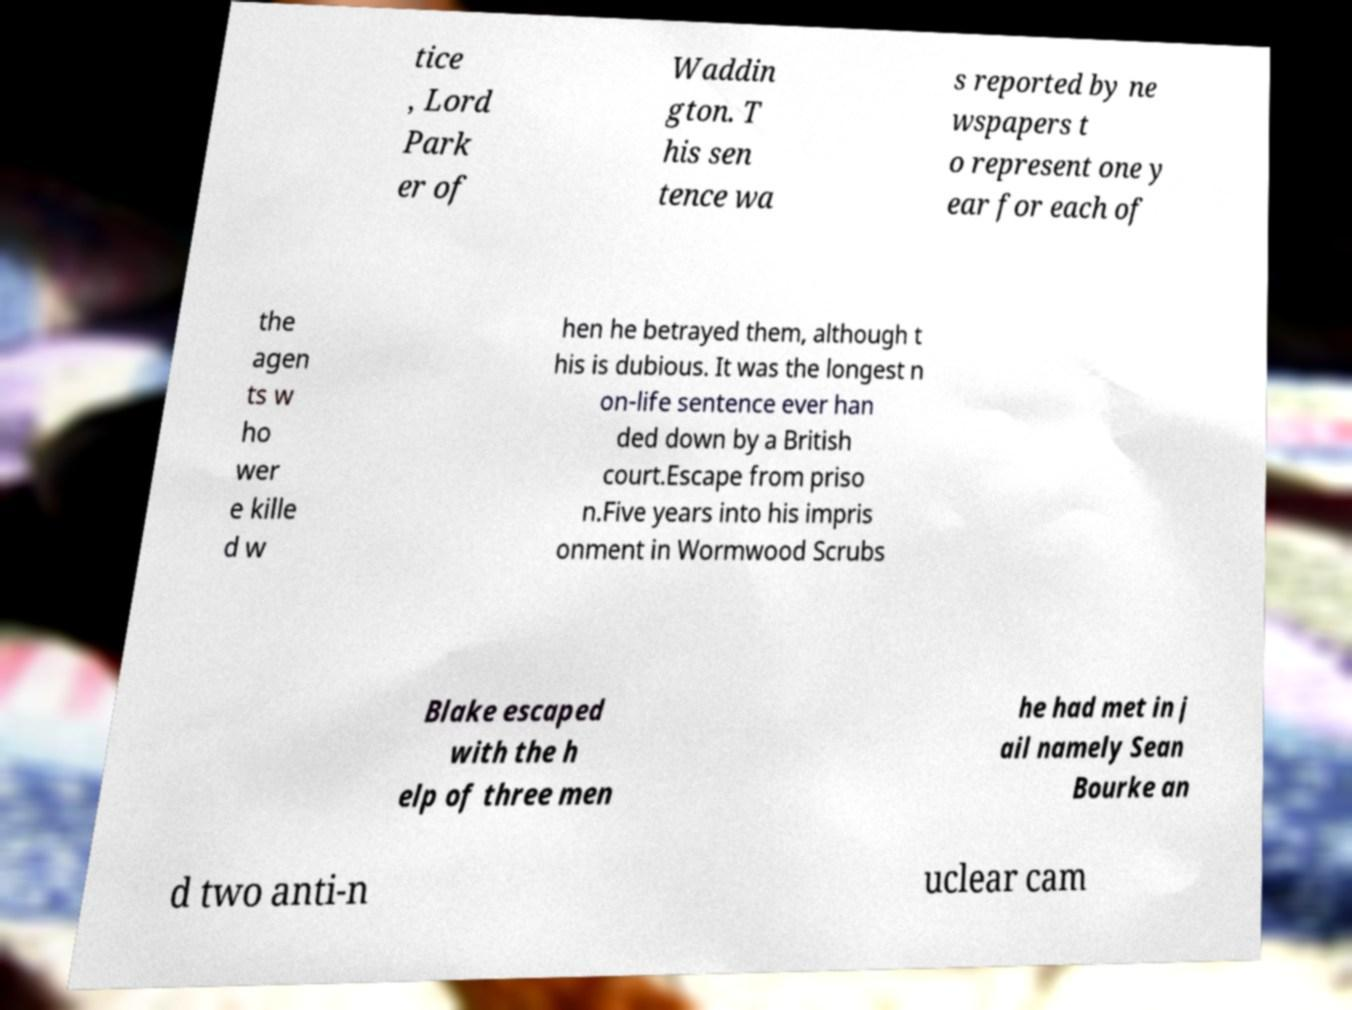For documentation purposes, I need the text within this image transcribed. Could you provide that? tice , Lord Park er of Waddin gton. T his sen tence wa s reported by ne wspapers t o represent one y ear for each of the agen ts w ho wer e kille d w hen he betrayed them, although t his is dubious. It was the longest n on-life sentence ever han ded down by a British court.Escape from priso n.Five years into his impris onment in Wormwood Scrubs Blake escaped with the h elp of three men he had met in j ail namely Sean Bourke an d two anti-n uclear cam 